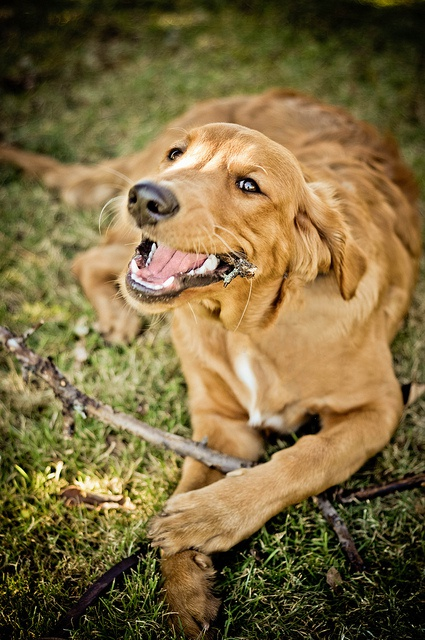Describe the objects in this image and their specific colors. I can see dog in black, tan, and olive tones and dog in black, tan, and olive tones in this image. 